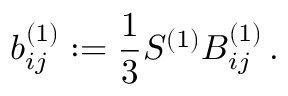Convert formula to latex. <formula><loc_0><loc_0><loc_500><loc_500>b _ { i j } ^ { ( 1 ) } \colon = \frac { 1 } { 3 } S ^ { ( 1 ) } B _ { i j } ^ { ( 1 ) } \, .</formula> 